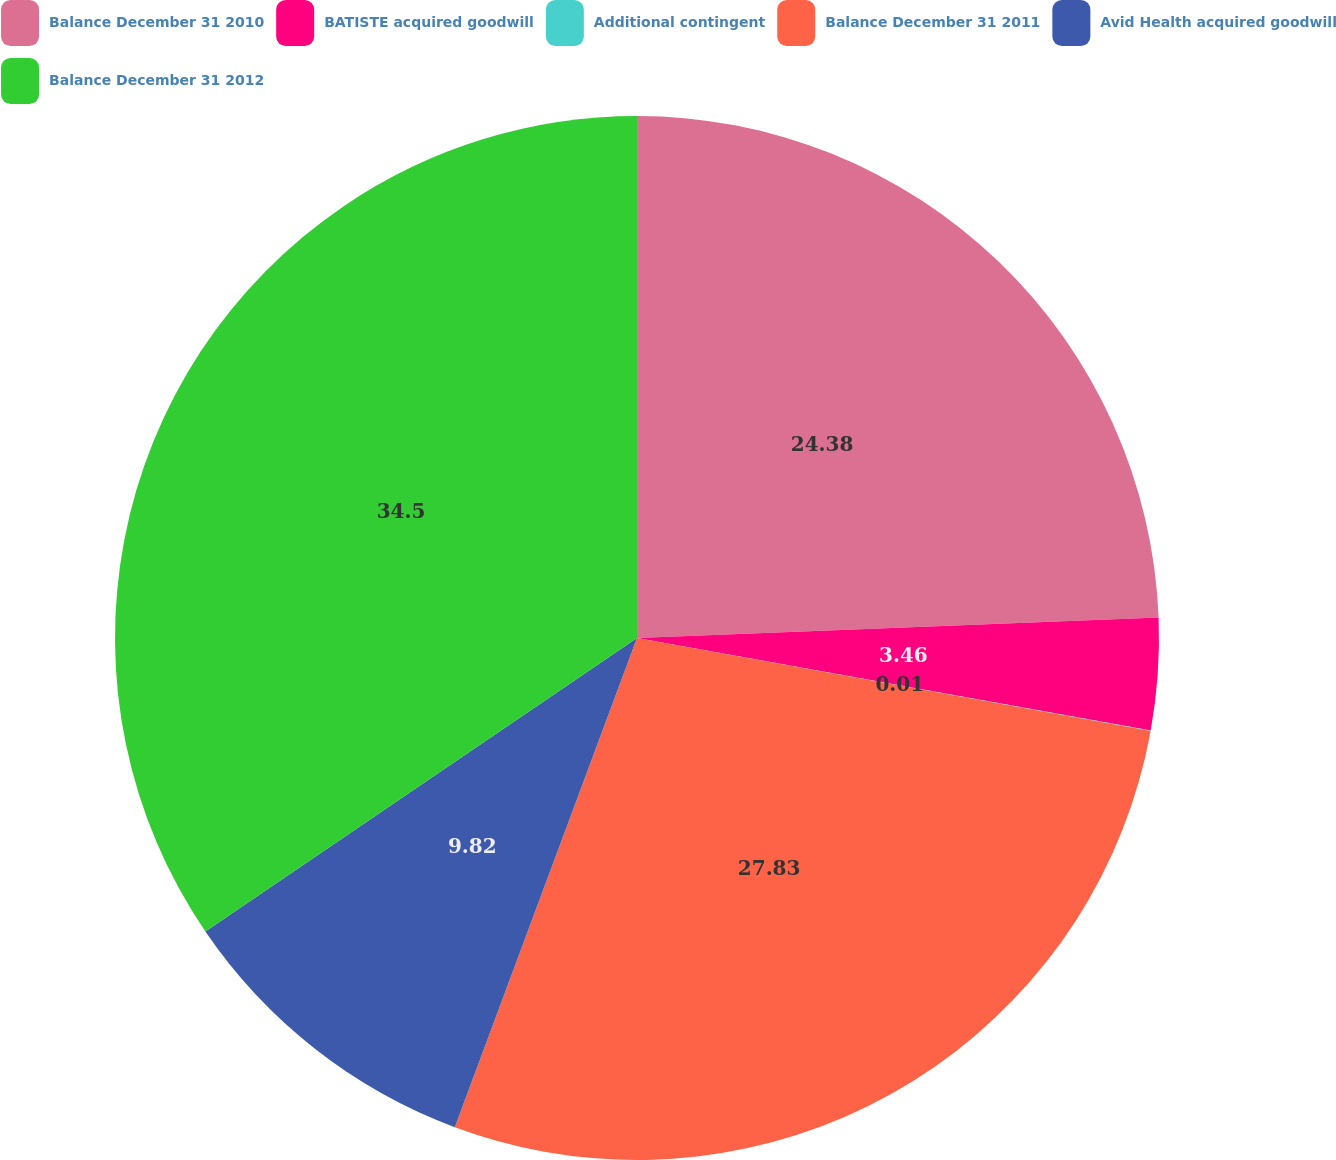Convert chart. <chart><loc_0><loc_0><loc_500><loc_500><pie_chart><fcel>Balance December 31 2010<fcel>BATISTE acquired goodwill<fcel>Additional contingent<fcel>Balance December 31 2011<fcel>Avid Health acquired goodwill<fcel>Balance December 31 2012<nl><fcel>24.38%<fcel>3.46%<fcel>0.01%<fcel>27.83%<fcel>9.82%<fcel>34.51%<nl></chart> 